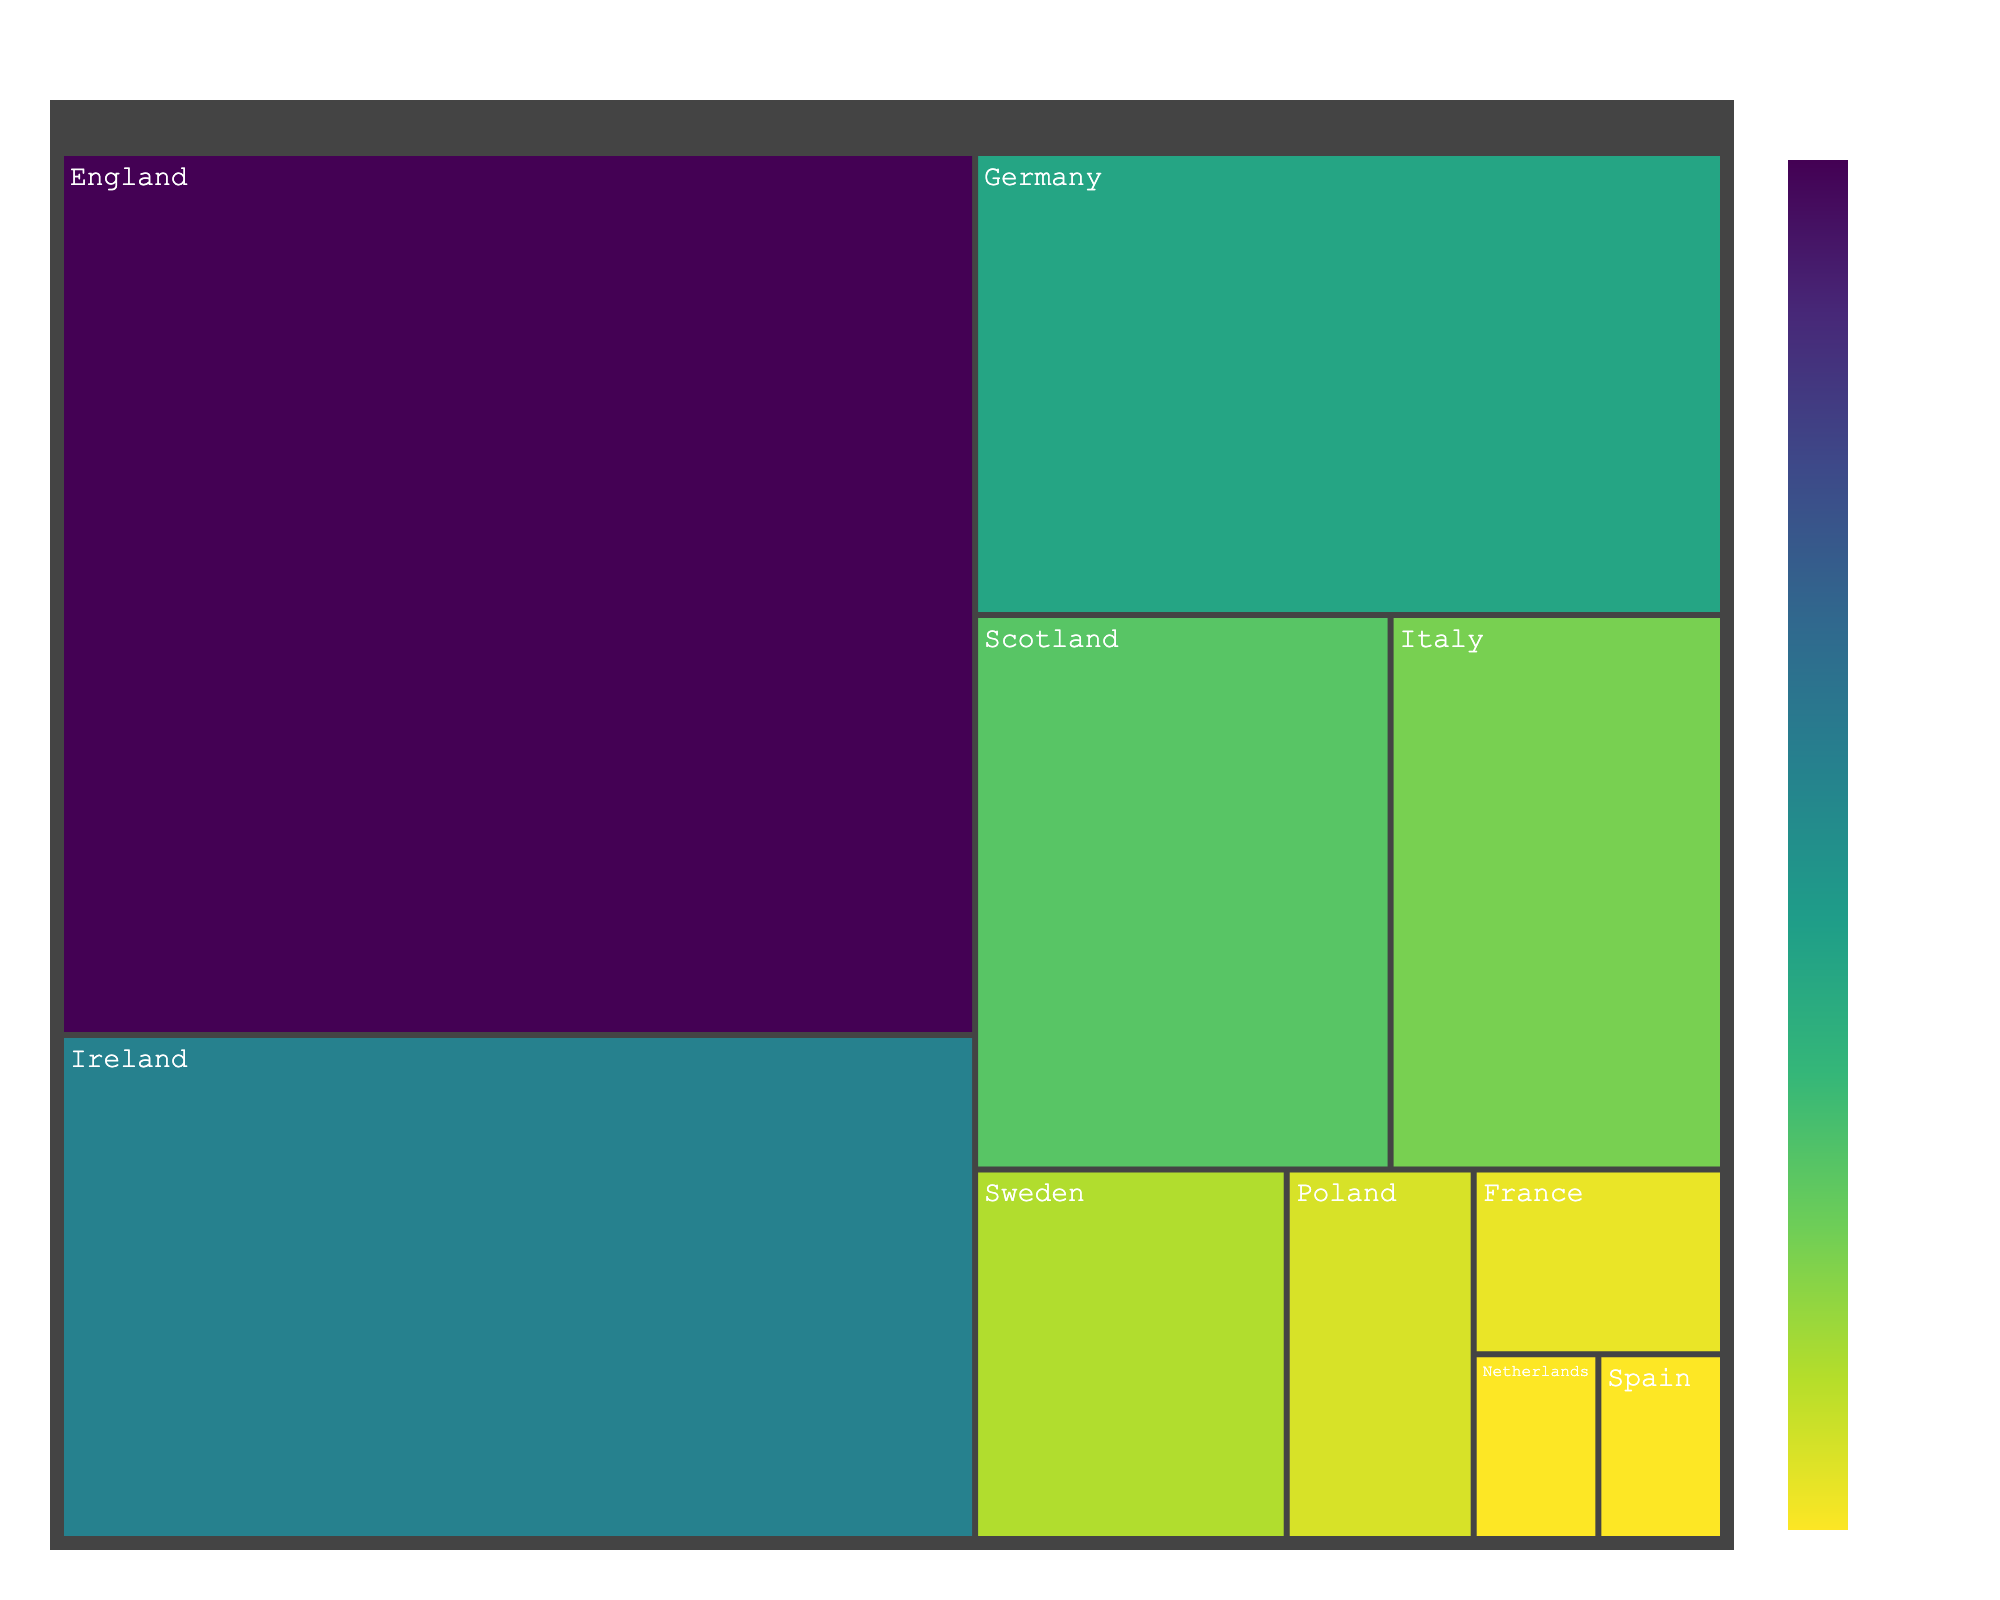What is the country with the highest percentage of ancestral origins? The country with the highest percentage will be the largest block and typically at the top or center of the treemap.
Answer: England Which two countries have the smallest percentage of ancestral origins? The two countries with the smallest percentages will be the smallest blocks.
Answer: Netherlands and Spain What is the combined percentage of ancestral origins from Germany and Scotland? Add the percentages of Germany and Scotland. Germany: 15%, Scotland: 10%. Therefore, 15% + 10% = 25%.
Answer: 25% Which country has a higher ancestral origin percentage, Italy or Sweden? Compare the percentages of Italy and Sweden. Italy has 8%, and Sweden has 5%, so Italy has a higher percentage.
Answer: Italy How much greater is England's ancestral origin percentage compared to Ireland's? Subtract Ireland's percentage from England's percentage - 35% (England) - 20% (Ireland) = 15%.
Answer: 15% What percentage of ancestral origins comes from Northern European countries (England, Ireland, Scotland, and Sweden)? Add the percentages from England, Ireland, Scotland, and Sweden: 35% + 20% + 10% + 5% = 70%.
Answer: 70% What is the percentage difference between the country with the highest ancestral origin and the country with the lowest? Subtract the smallest percentage from the largest percentage: 35% (England) - 1% (Netherlands or Spain) = 34%.
Answer: 34% Which countries together constitute over half of the ancestral origins' percentage? Add the top percentages until the sum exceeds 50%. Adding England (35%), Ireland (20%) gives 55%, which is already over half.
Answer: England and Ireland How many countries have an ancestral origin percentage of 10% or more? Count the blocks with a percentage of 10% or more. England (35%), Ireland (20%), Germany (15%), and Scotland (10%) - 4 countries.
Answer: 4 What is the average percentage of ancestral origins for all the countries listed? Calculate the average by summing the percentages and dividing by the number of countries: (35 + 20 + 15 + 10 + 8 + 5 + 3 + 2 + 1 + 1)/10 = 100/10 = 10%.
Answer: 10% 